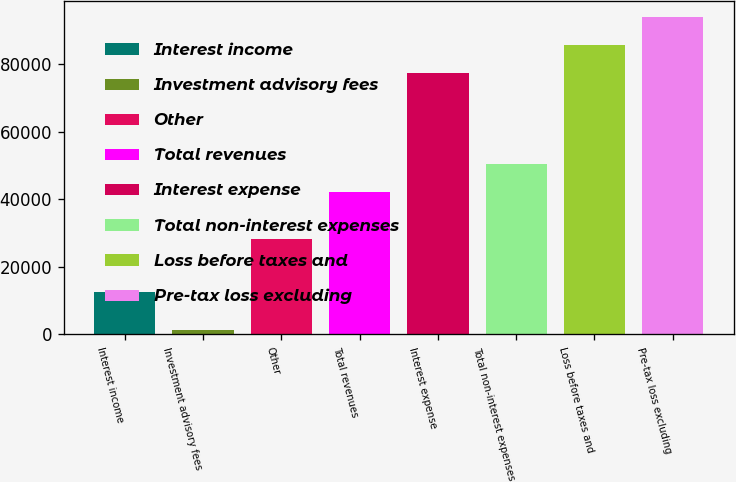Convert chart. <chart><loc_0><loc_0><loc_500><loc_500><bar_chart><fcel>Interest income<fcel>Investment advisory fees<fcel>Other<fcel>Total revenues<fcel>Interest expense<fcel>Total non-interest expenses<fcel>Loss before taxes and<fcel>Pre-tax loss excluding<nl><fcel>12549<fcel>1340<fcel>28314<fcel>42203<fcel>77456<fcel>50460.8<fcel>85713.8<fcel>93971.6<nl></chart> 